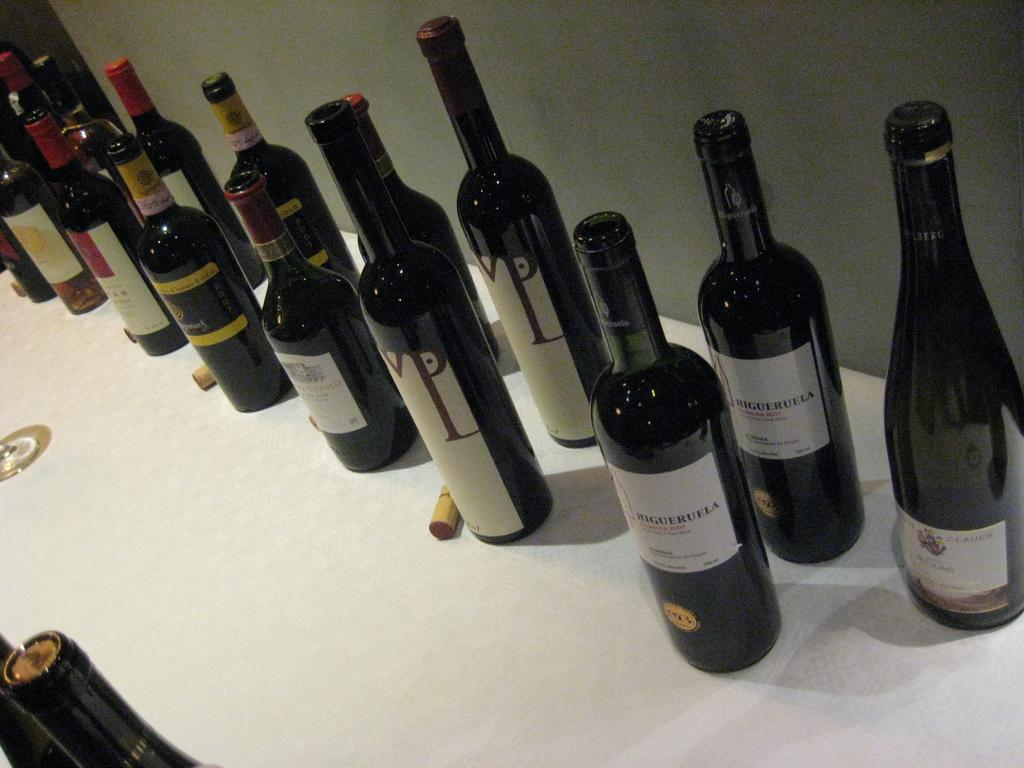What is the color of the table in the image? The table in the image is white. What objects are placed on the table? Many glass bottles are placed on the table. What might be the contents of the bottles? The bottles might be alcohol bottles. What can be seen in the background of the image? There is a grey color wall in the background of the image. What type of power source is visible in the image? There is no power source visible in the image. What flag is being displayed in the image? There is no flag present in the image. 